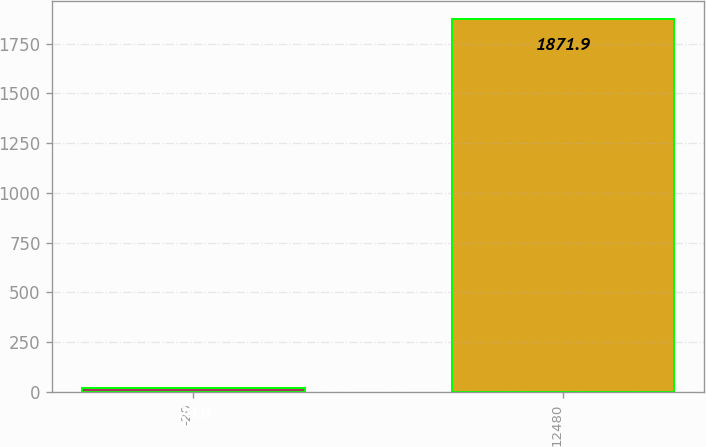<chart> <loc_0><loc_0><loc_500><loc_500><bar_chart><fcel>-20<fcel>12480<nl><fcel>20<fcel>1871.9<nl></chart> 